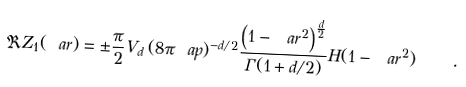Convert formula to latex. <formula><loc_0><loc_0><loc_500><loc_500>\Re Z _ { 1 } ( \ a r ) = \pm \frac { \pi } { 2 } V _ { d } \, ( 8 \pi \ a p ) ^ { - d / 2 } \frac { \left ( 1 - \ a r ^ { 2 } \right ) ^ { \frac { d } { 2 } } } { \Gamma ( 1 + d / 2 ) } H ( 1 - \ a r ^ { 2 } ) \quad .</formula> 